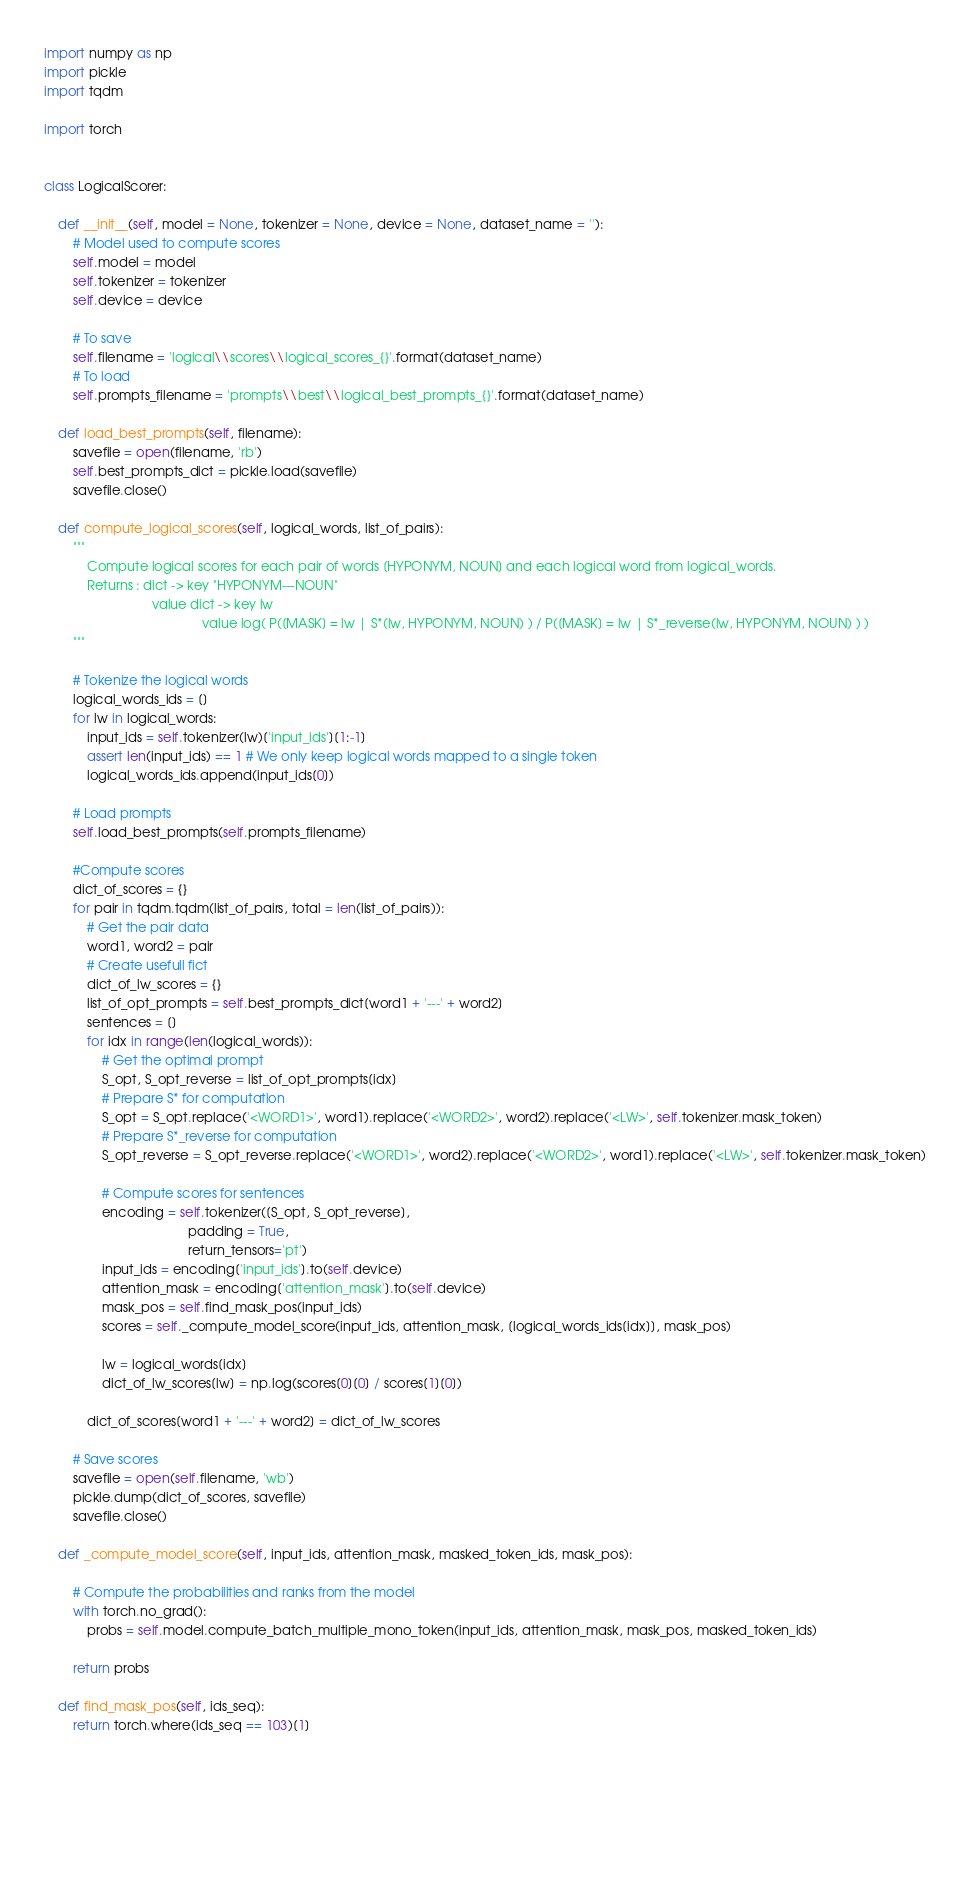Convert code to text. <code><loc_0><loc_0><loc_500><loc_500><_Python_>
import numpy as np
import pickle
import tqdm

import torch


class LogicalScorer:

    def __init__(self, model = None, tokenizer = None, device = None, dataset_name = ''):
        # Model used to compute scores
        self.model = model
        self.tokenizer = tokenizer
        self.device = device

        # To save
        self.filename = 'logical\\scores\\logical_scores_{}'.format(dataset_name)
        # To load
        self.prompts_filename = 'prompts\\best\\logical_best_prompts_{}'.format(dataset_name)

    def load_best_prompts(self, filename):
        savefile = open(filename, 'rb')
        self.best_prompts_dict = pickle.load(savefile)
        savefile.close()

    def compute_logical_scores(self, logical_words, list_of_pairs):
        """
            Compute logical scores for each pair of words [HYPONYM, NOUN] and each logical word from logical_words.
            Returns : dict -> key "HYPONYM---NOUN"
                              value dict -> key lw
                                            value log( P([MASK] = lw | S*(lw, HYPONYM, NOUN) ) / P([MASK] = lw | S*_reverse(lw, HYPONYM, NOUN) ) )
        """

        # Tokenize the logical words
        logical_words_ids = []
        for lw in logical_words:
            input_ids = self.tokenizer(lw)['input_ids'][1:-1]
            assert len(input_ids) == 1 # We only keep logical words mapped to a single token
            logical_words_ids.append(input_ids[0])

        # Load prompts
        self.load_best_prompts(self.prompts_filename)

        #Compute scores
        dict_of_scores = {}
        for pair in tqdm.tqdm(list_of_pairs, total = len(list_of_pairs)):
            # Get the pair data
            word1, word2 = pair
            # Create usefull fict
            dict_of_lw_scores = {}
            list_of_opt_prompts = self.best_prompts_dict[word1 + '---' + word2]
            sentences = []
            for idx in range(len(logical_words)):
                # Get the optimal prompt
                S_opt, S_opt_reverse = list_of_opt_prompts[idx]
                # Prepare S* for computation
                S_opt = S_opt.replace('<WORD1>', word1).replace('<WORD2>', word2).replace('<LW>', self.tokenizer.mask_token)
                # Prepare S*_reverse for computation
                S_opt_reverse = S_opt_reverse.replace('<WORD1>', word2).replace('<WORD2>', word1).replace('<LW>', self.tokenizer.mask_token)

                # Compute scores for sentences
                encoding = self.tokenizer([S_opt, S_opt_reverse],
                                        padding = True,
                                        return_tensors='pt')
                input_ids = encoding['input_ids'].to(self.device)
                attention_mask = encoding['attention_mask'].to(self.device)
                mask_pos = self.find_mask_pos(input_ids)
                scores = self._compute_model_score(input_ids, attention_mask, [logical_words_ids[idx]], mask_pos)

                lw = logical_words[idx]
                dict_of_lw_scores[lw] = np.log(scores[0][0] / scores[1][0])

            dict_of_scores[word1 + '---' + word2] = dict_of_lw_scores

        # Save scores
        savefile = open(self.filename, 'wb')
        pickle.dump(dict_of_scores, savefile)
        savefile.close()

    def _compute_model_score(self, input_ids, attention_mask, masked_token_ids, mask_pos):

        # Compute the probabilities and ranks from the model
        with torch.no_grad():
            probs = self.model.compute_batch_multiple_mono_token(input_ids, attention_mask, mask_pos, masked_token_ids)

        return probs

    def find_mask_pos(self, ids_seq):
        return torch.where(ids_seq == 103)[1]

        
        

        
        
</code> 